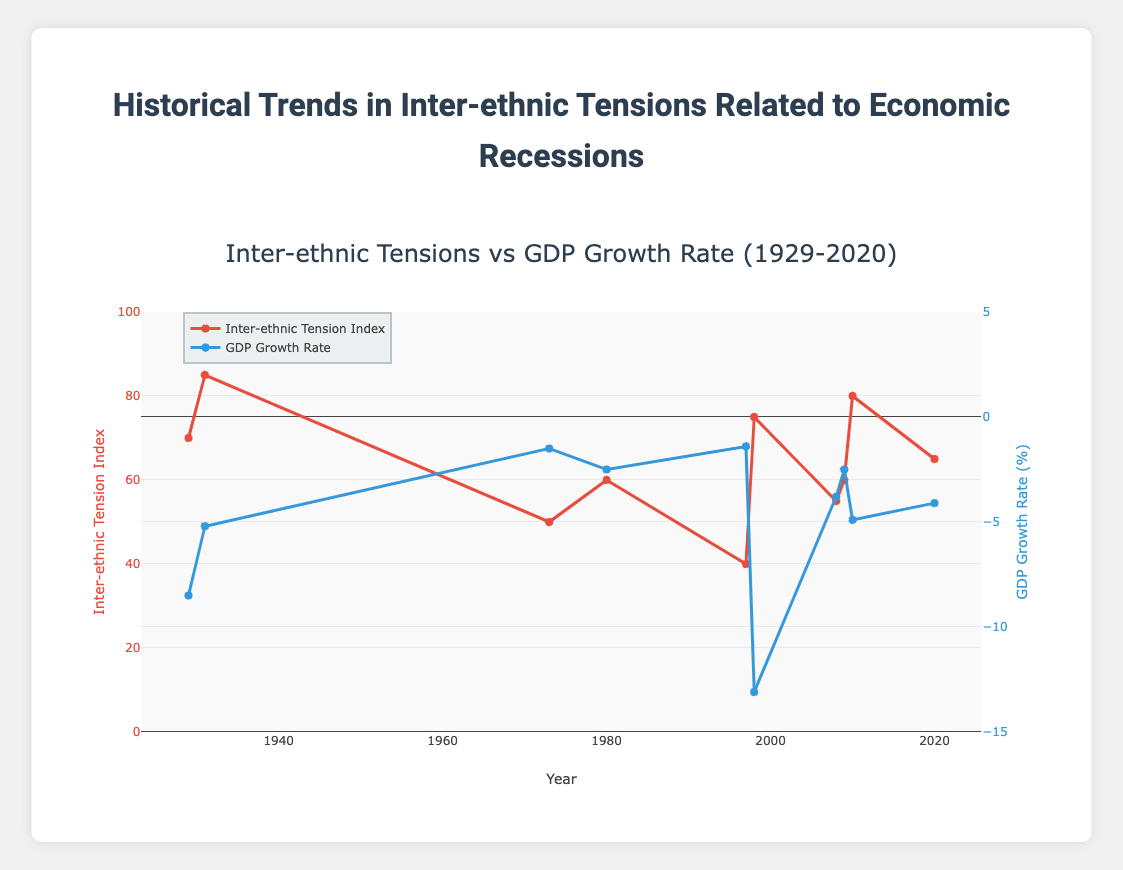What's the highest Inter-ethnic Tension Index shown in the plot and in which year did it occur? The highest Inter-ethnic Tension Index can be determined by examining the vertical positioning of the red lines and markers on the left y-axis. The highest peak is at 85, which occurred in the year 1931.
Answer: 1931 How does the Inter-ethnic Tension Index of 1998 Indonesia compare to the 2010 Greece? Observe the red markers for 1998 and 2010. For Indonesia in 1998, the index is 75, while for Greece in 2010 it is 80. Compare the two values; the index for Greece in 2010 is higher.
Answer: Greece in 2010 has a higher index Which country experienced the most significant economic contraction based on GDP Growth Rate and what was its rate? Look at the lowest point of the blue line on the right y-axis (GDP Growth Rate). The lowest point is -13.1%, which was experienced by Indonesia in 1998.
Answer: Indonesia, -13.1% In which year did the United States appear on the plot, and what were the corresponding Inter-ethnic Tension Index and GDP Growth Rate for that year? There are two years where the United States appears, 1929 and 2009. For 1929, the Inter-ethnic Tension Index is 70 and the GDP Growth Rate is -8.5. For 2009, the index is 60 and the GDP Growth Rate is -2.5.
Answer: 1929: 70, -8.5; 2009: 60, -2.5 What's the difference in the Inter-ethnic Tension Index between Thailand in 1997 and Argentina in 1980? Locate the red markers for 1997 (Thailand) and 1980 (Argentina). For 1997 Thailand, the index is 40. For 1980 Argentina, the index is 60. The difference is 60 - 40 = 20.
Answer: 20 Which country had a higher GDP Growth Rate, the United Kingdom in 1973 or Spain in 2008? Compare the blue markers for 1973 and 2008. For the United Kingdom in 1973, the GDP Growth Rate is -1.5%. For Spain in 2008, it is -3.8%. Therefore, the United Kingdom in 1973 had a higher rate.
Answer: United Kingdom in 1973 What is the average Inter-ethnic Tension Index across all data points shown in the figure? Sum all the Inter-ethnic Tension Index values: 70 + 85 + 50 + 60 + 40 + 75 + 55 + 60 + 80 + 65 = 640. There are 10 data points. The average is 640 / 10 = 64.
Answer: 64 Which year had higher Inter-ethnic Tension Index and lower GDP Growth Rate, 2020 Brazil or 2010 Greece? Compare the markers for 2020 (Brazil) and 2010 (Greece). Brazil in 2020 has an Inter-ethnic Tension Index of 65 and GDP Growth Rate of -4.1. Greece in 2010 has an index of 80 and GDP Growth Rate of -4.9. Greece had a higher index and lower growth rate.
Answer: 2010 Greece 